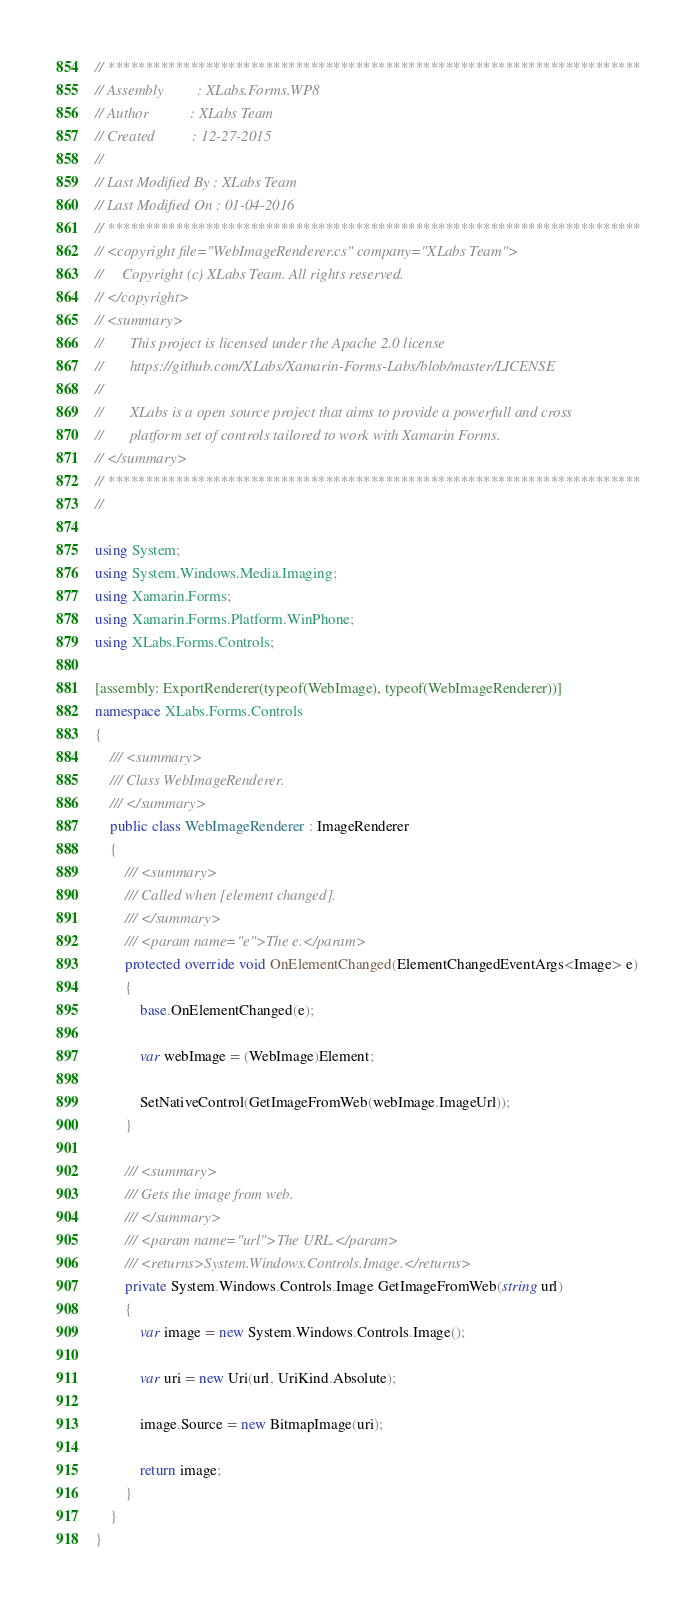Convert code to text. <code><loc_0><loc_0><loc_500><loc_500><_C#_>// ***********************************************************************
// Assembly         : XLabs.Forms.WP8
// Author           : XLabs Team
// Created          : 12-27-2015
// 
// Last Modified By : XLabs Team
// Last Modified On : 01-04-2016
// ***********************************************************************
// <copyright file="WebImageRenderer.cs" company="XLabs Team">
//     Copyright (c) XLabs Team. All rights reserved.
// </copyright>
// <summary>
//       This project is licensed under the Apache 2.0 license
//       https://github.com/XLabs/Xamarin-Forms-Labs/blob/master/LICENSE
//       
//       XLabs is a open source project that aims to provide a powerfull and cross 
//       platform set of controls tailored to work with Xamarin Forms.
// </summary>
// ***********************************************************************
// 

using System;
using System.Windows.Media.Imaging;
using Xamarin.Forms;
using Xamarin.Forms.Platform.WinPhone;
using XLabs.Forms.Controls;

[assembly: ExportRenderer(typeof(WebImage), typeof(WebImageRenderer))]
namespace XLabs.Forms.Controls
{
	/// <summary>
	/// Class WebImageRenderer.
	/// </summary>
	public class WebImageRenderer : ImageRenderer
	{
		/// <summary>
		/// Called when [element changed].
		/// </summary>
		/// <param name="e">The e.</param>
		protected override void OnElementChanged(ElementChangedEventArgs<Image> e)
		{
			base.OnElementChanged(e);

			var webImage = (WebImage)Element;

			SetNativeControl(GetImageFromWeb(webImage.ImageUrl));
		}

		/// <summary>
		/// Gets the image from web.
		/// </summary>
		/// <param name="url">The URL.</param>
		/// <returns>System.Windows.Controls.Image.</returns>
		private System.Windows.Controls.Image GetImageFromWeb(string url)
		{
			var image = new System.Windows.Controls.Image();

			var uri = new Uri(url, UriKind.Absolute);

			image.Source = new BitmapImage(uri);

			return image;
		}
	}
}</code> 